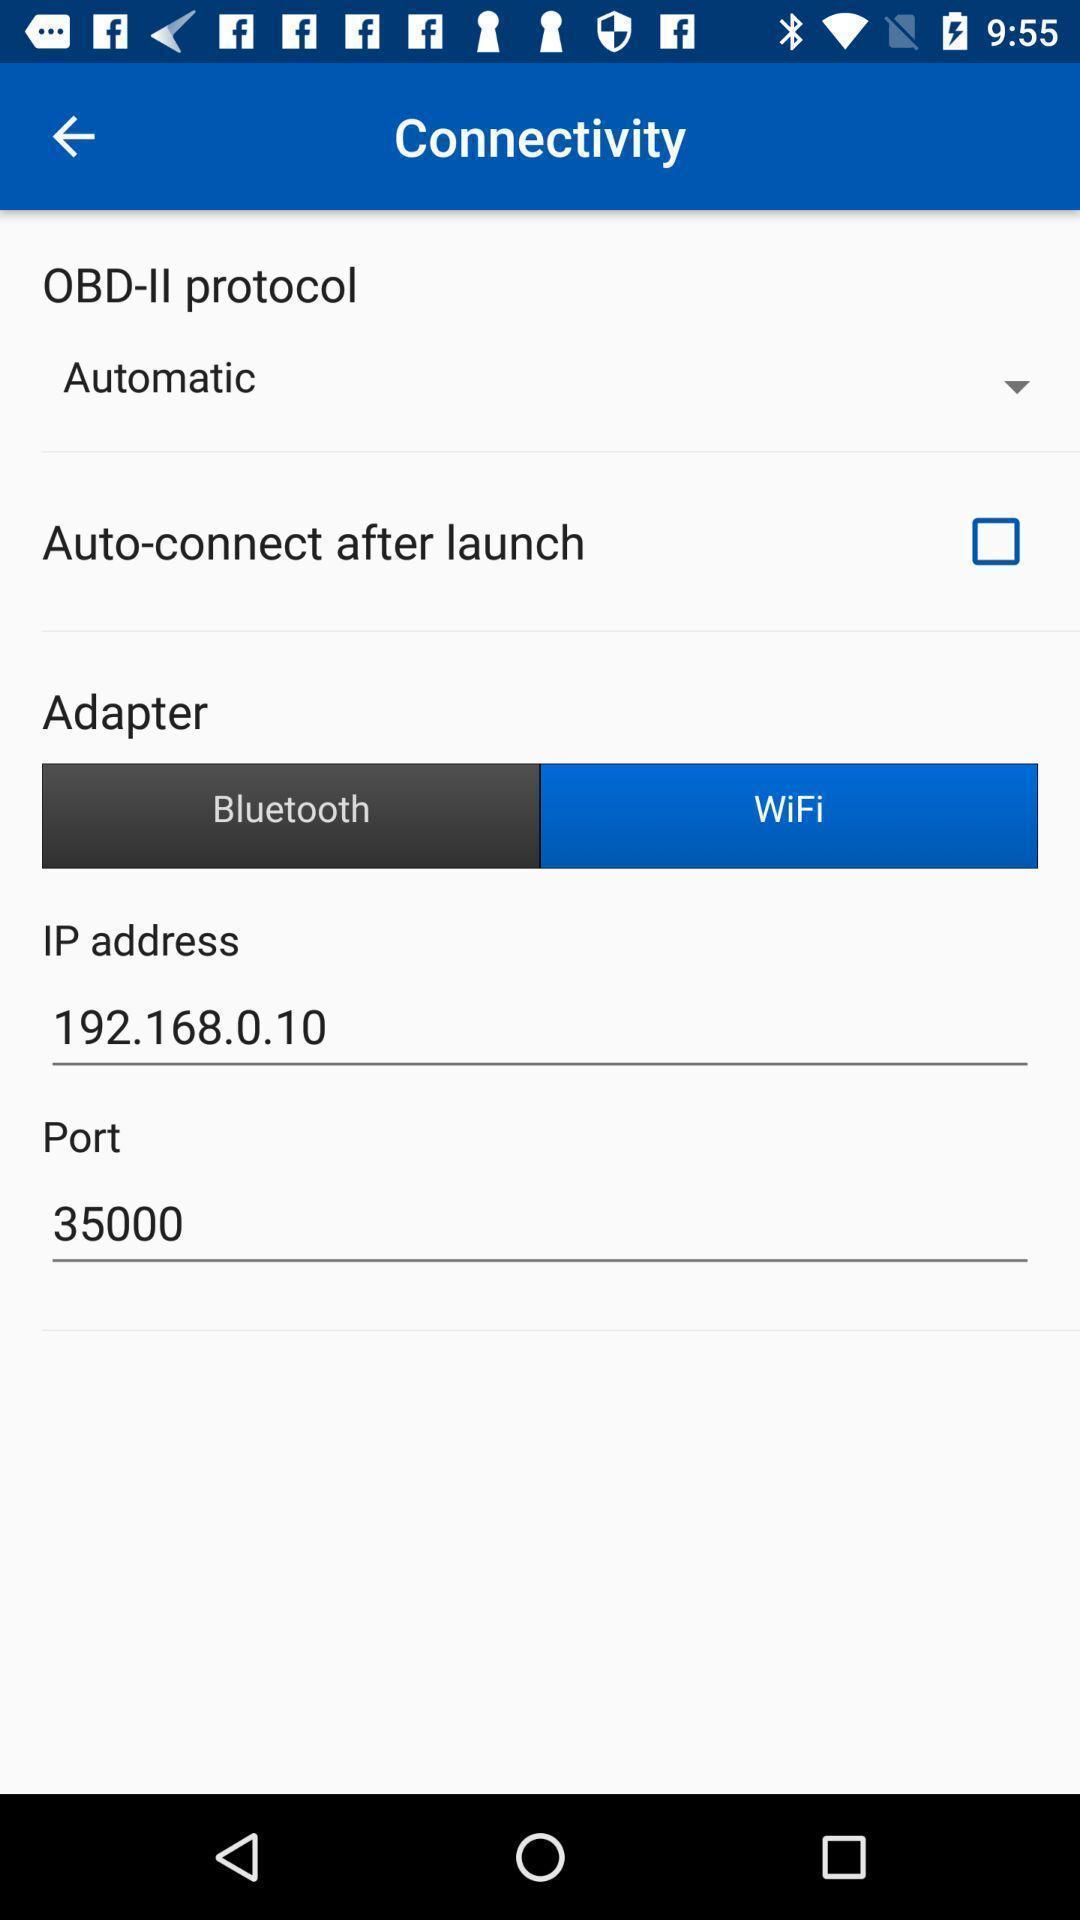Describe this image in words. Page displaying various details. 